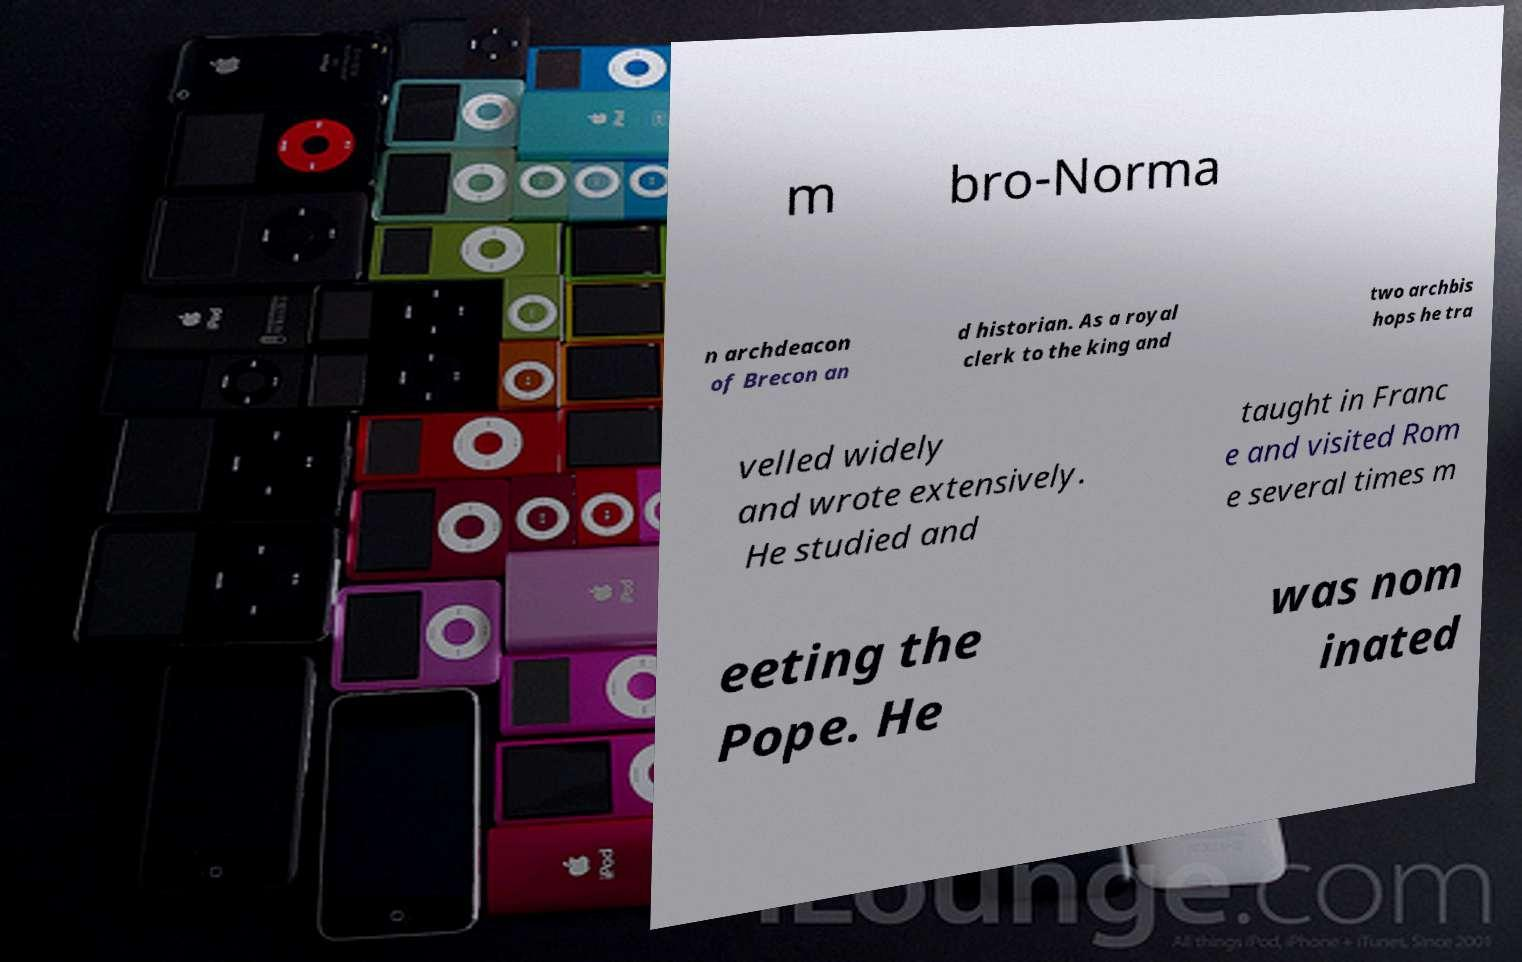What messages or text are displayed in this image? I need them in a readable, typed format. m bro-Norma n archdeacon of Brecon an d historian. As a royal clerk to the king and two archbis hops he tra velled widely and wrote extensively. He studied and taught in Franc e and visited Rom e several times m eeting the Pope. He was nom inated 